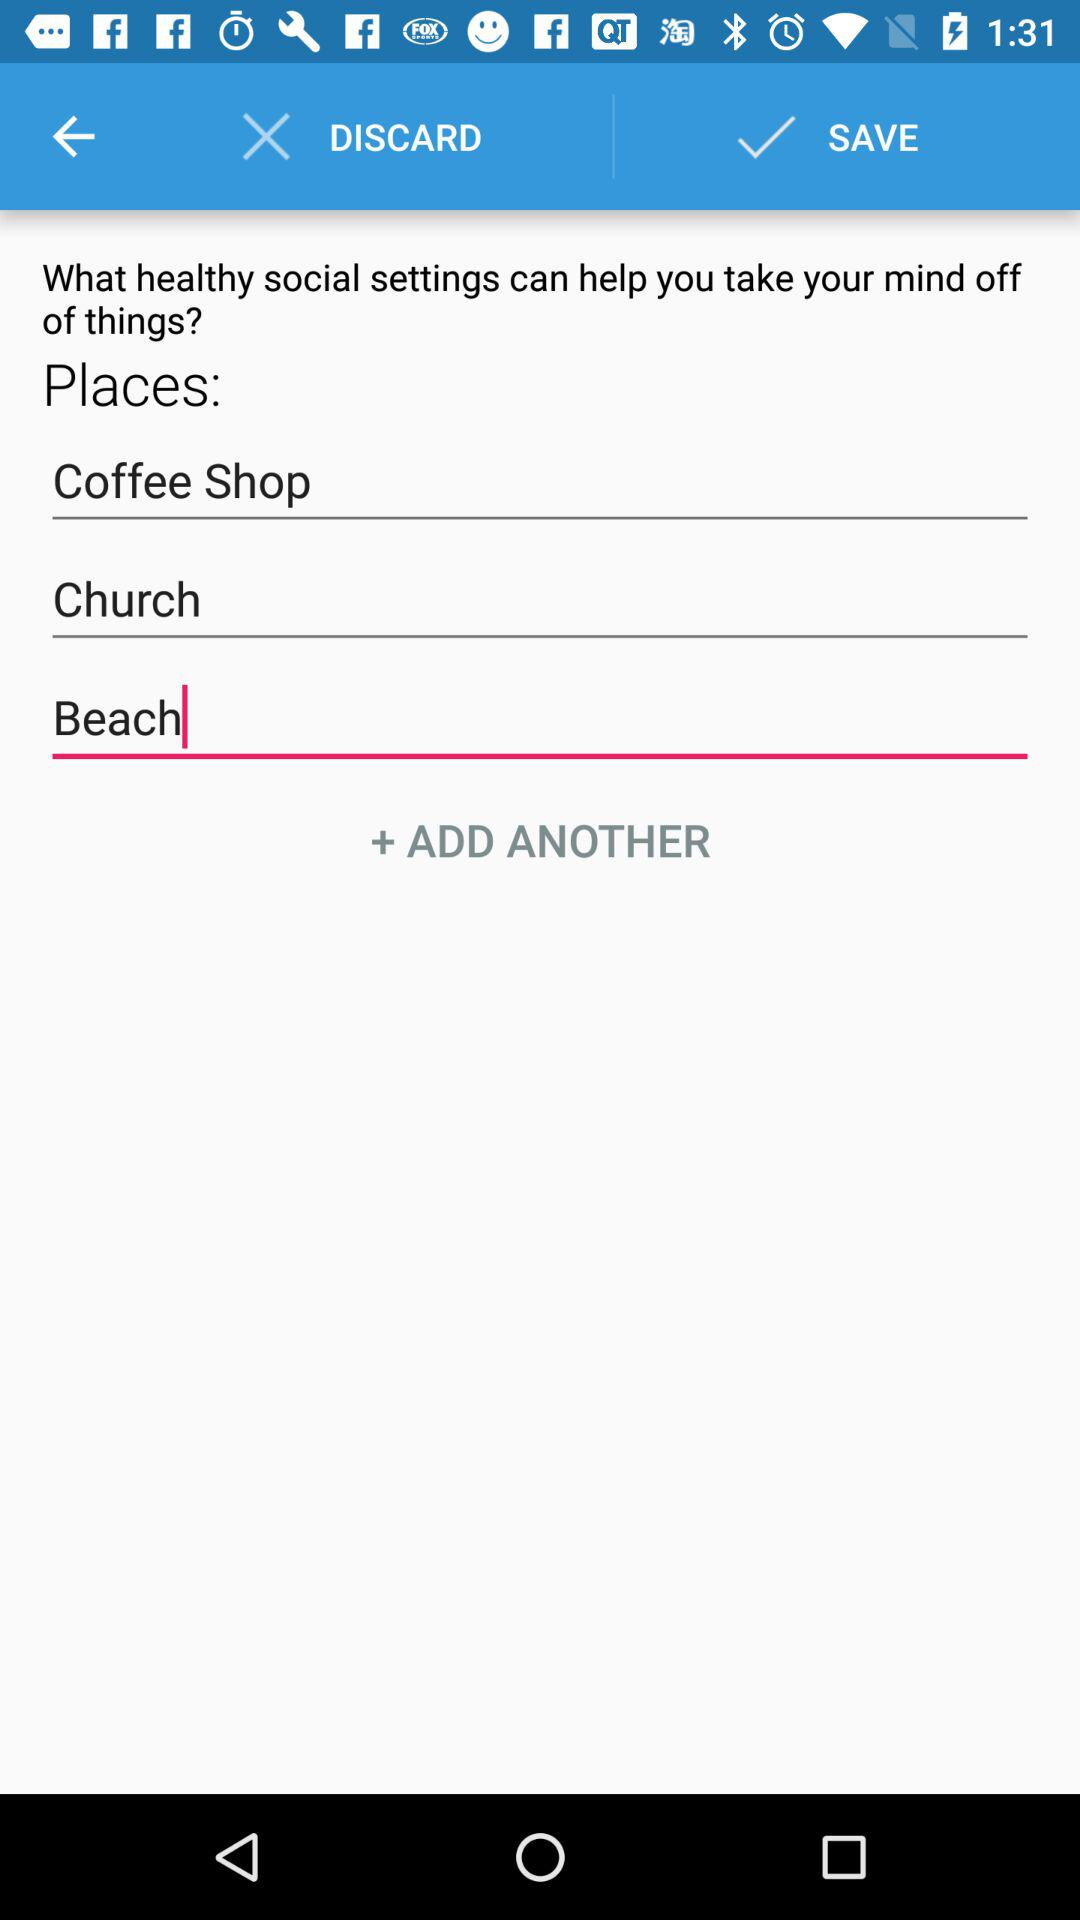How many places can I add?
Answer the question using a single word or phrase. 3 